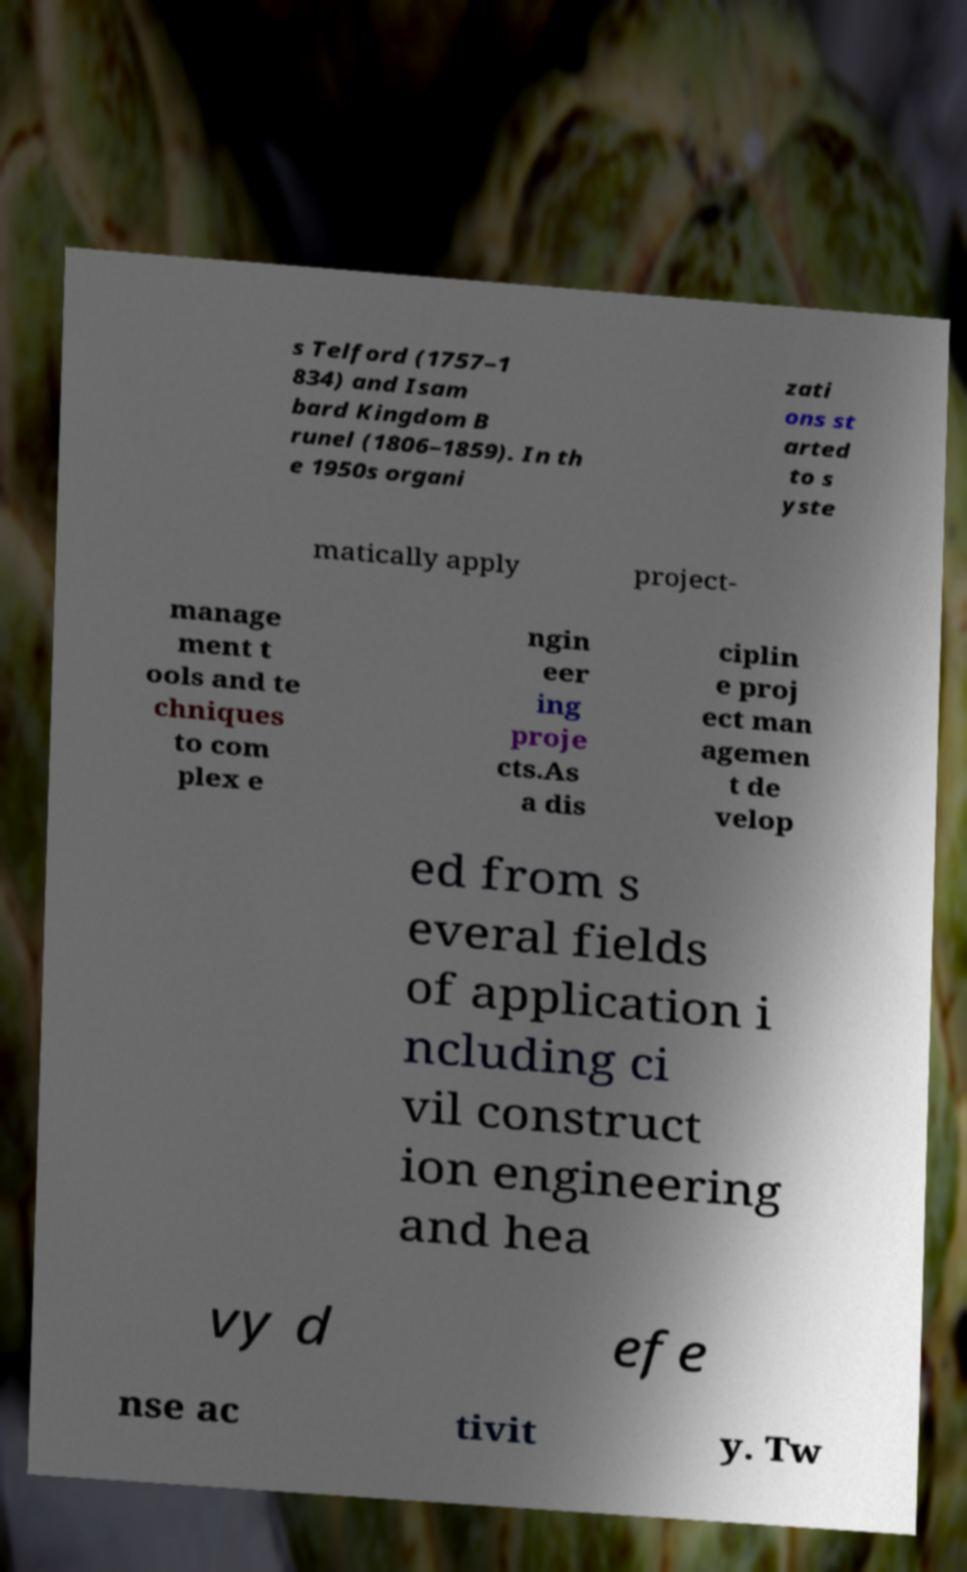Can you accurately transcribe the text from the provided image for me? s Telford (1757–1 834) and Isam bard Kingdom B runel (1806–1859). In th e 1950s organi zati ons st arted to s yste matically apply project- manage ment t ools and te chniques to com plex e ngin eer ing proje cts.As a dis ciplin e proj ect man agemen t de velop ed from s everal fields of application i ncluding ci vil construct ion engineering and hea vy d efe nse ac tivit y. Tw 